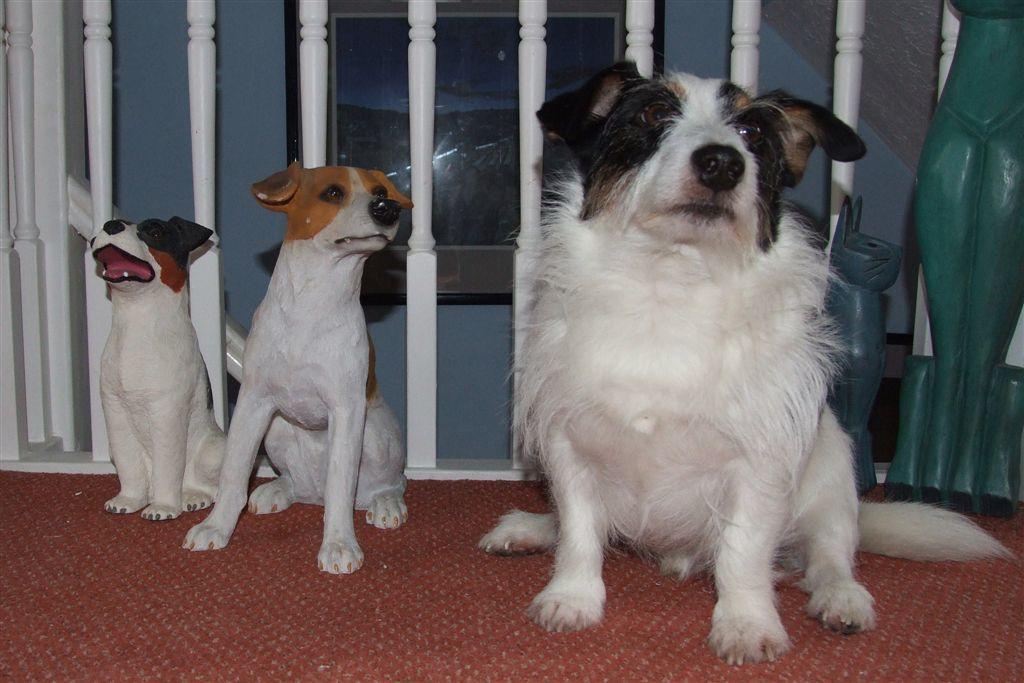In one or two sentences, can you explain what this image depicts? In this image we can see a dog standing on the floor and statues of dogs behind it. In the background there is a wall hanging attached to the wall and railings. 